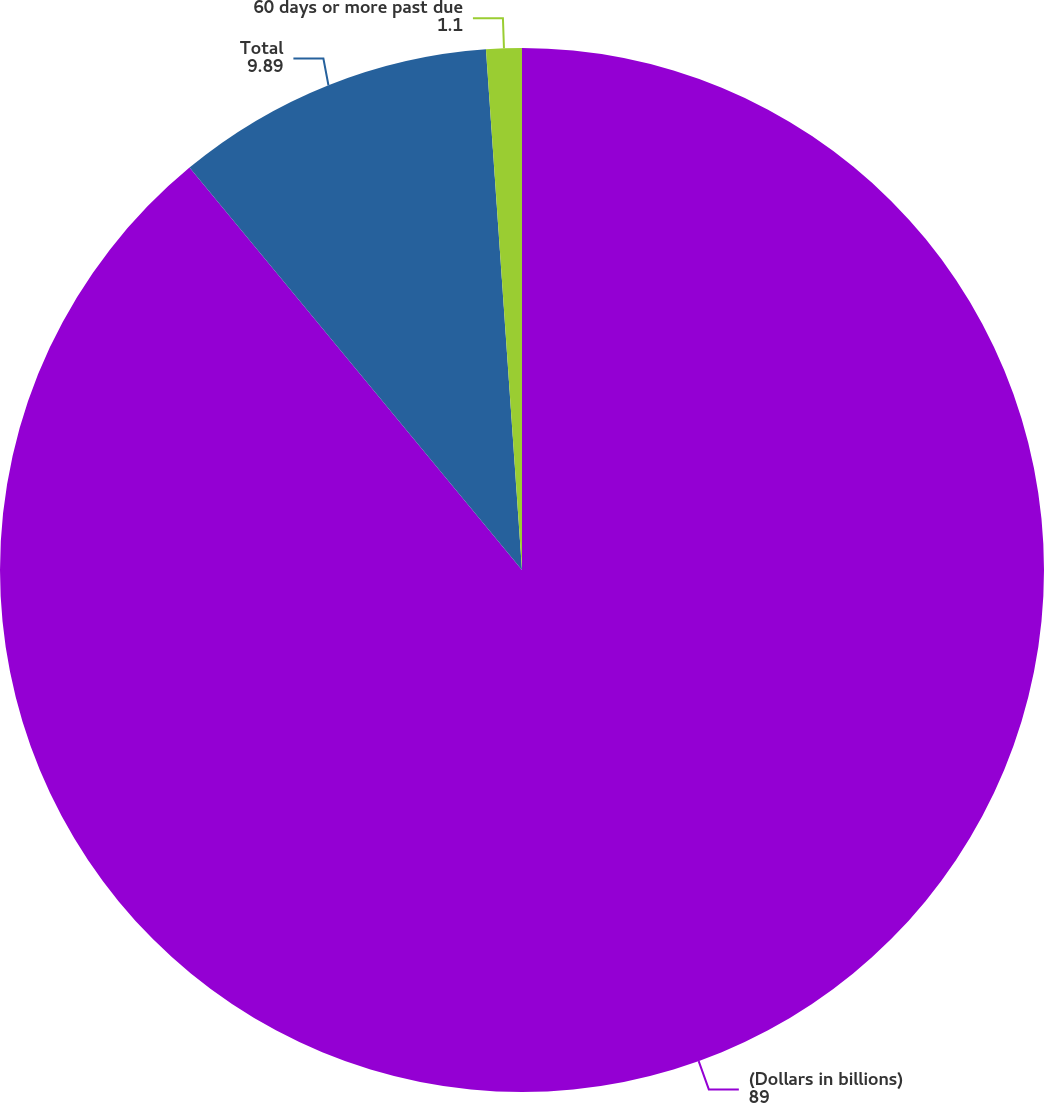<chart> <loc_0><loc_0><loc_500><loc_500><pie_chart><fcel>(Dollars in billions)<fcel>Total<fcel>60 days or more past due<nl><fcel>89.0%<fcel>9.89%<fcel>1.1%<nl></chart> 